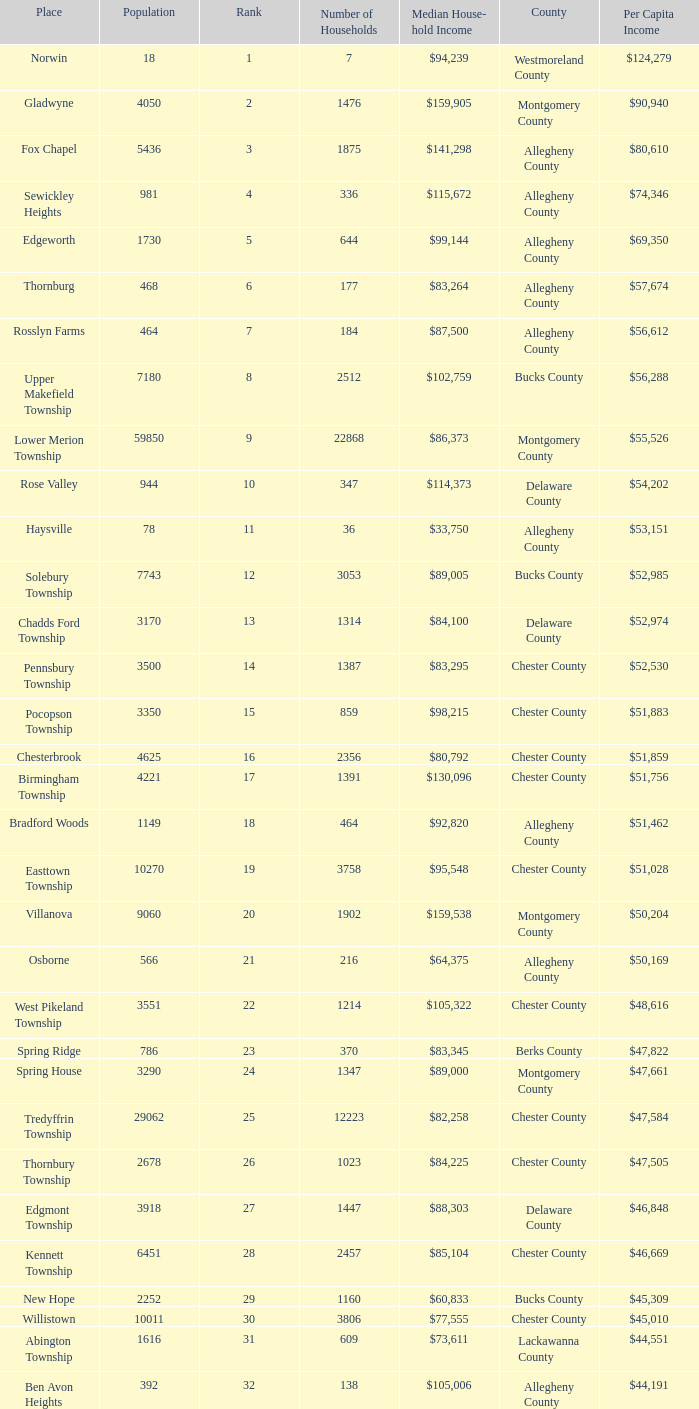What county has 2053 households?  Chester County. 